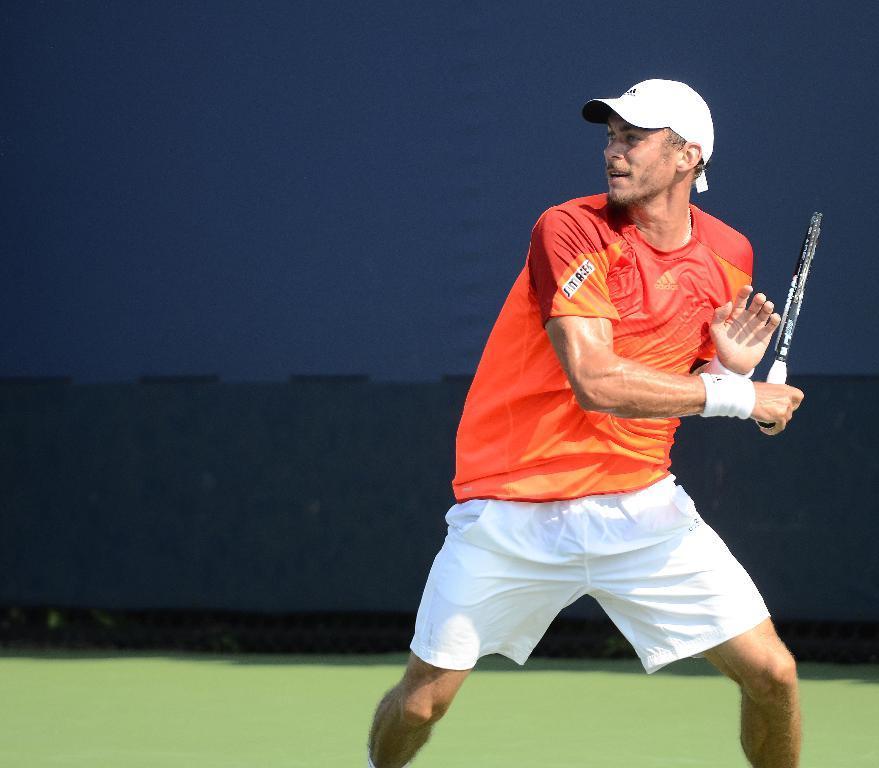Can you describe this image briefly? Here in this picture we can see a person standing in a court and we can see he is holding a tennis bat in his hand and he is motion and he also wearing a cap on him. 